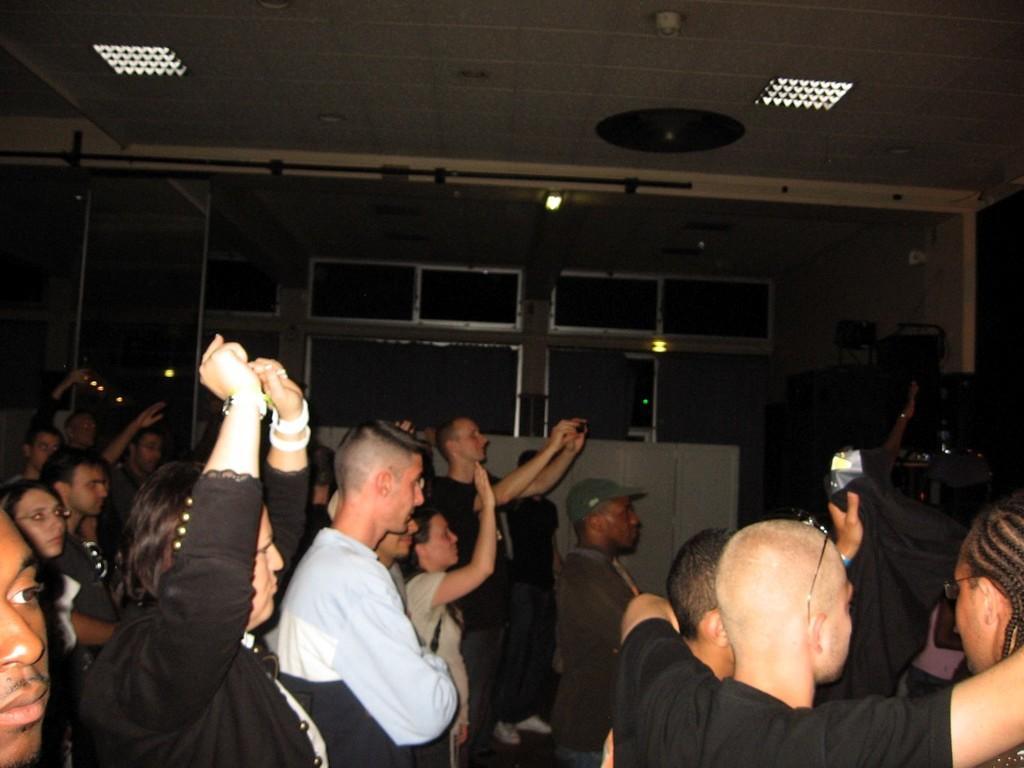In one or two sentences, can you explain what this image depicts? In this picture I can observe some people standing on the wall. There are men and women in this picture. In the background there are windows and a wall. 